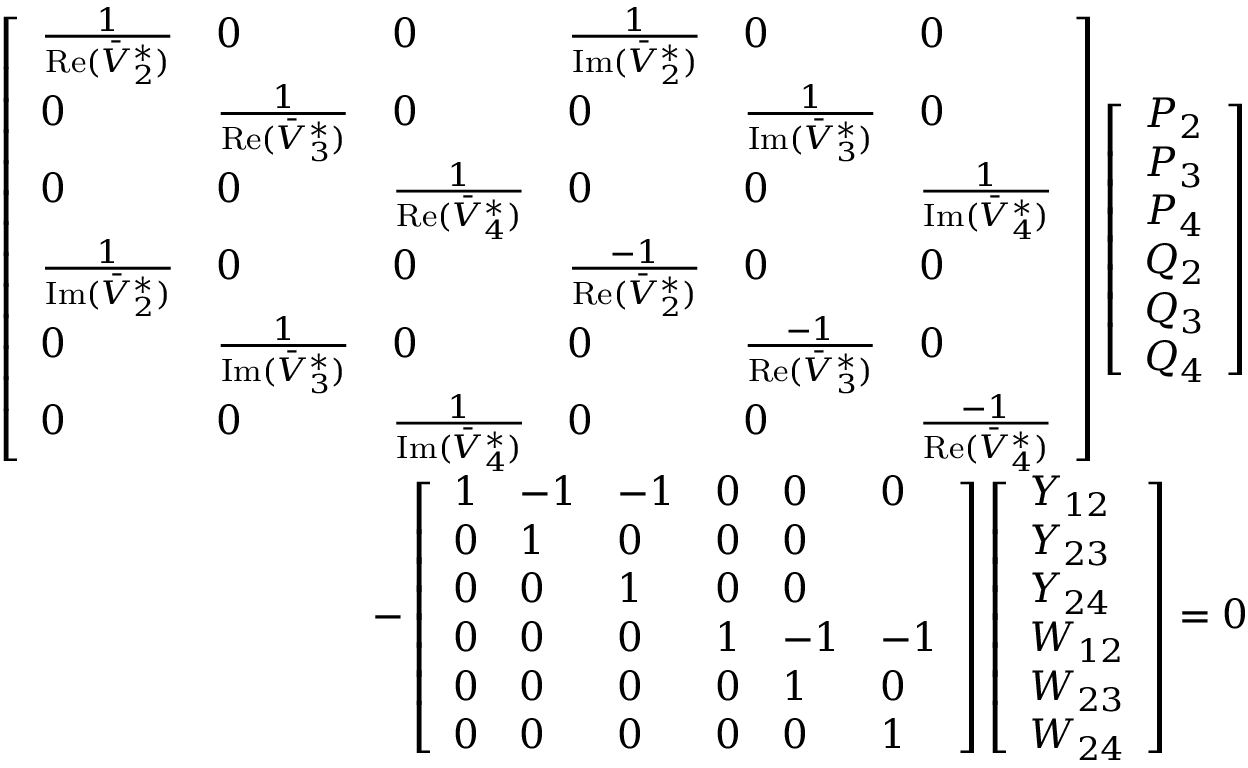Convert formula to latex. <formula><loc_0><loc_0><loc_500><loc_500>\begin{array} { r } { \left [ \begin{array} { l l l l l l } { \frac { 1 } { R e ( \bar { V } _ { 2 } ^ { * } ) } } & { 0 } & { 0 } & { \frac { 1 } { I m ( \bar { V } _ { 2 } ^ { * } ) } } & { 0 } & { 0 } \\ { 0 } & { \frac { 1 } { R e ( \bar { V } _ { 3 } ^ { * } ) } } & { 0 } & { 0 } & { \frac { 1 } { I m ( \bar { V } _ { 3 } ^ { * } ) } } & { 0 } \\ { 0 } & { 0 } & { \frac { 1 } { R e ( \bar { V } _ { 4 } ^ { * } ) } } & { 0 } & { 0 } & { \frac { 1 } { I m ( \bar { V } _ { 4 } ^ { * } ) } } \\ { \frac { 1 } { I m ( \bar { V } _ { 2 } ^ { * } ) } } & { 0 } & { 0 } & { \frac { - 1 } { R e ( \bar { V } _ { 2 } ^ { * } ) } } & { 0 } & { 0 } \\ { 0 } & { \frac { 1 } { I m ( \bar { V } _ { 3 } ^ { * } ) } } & { 0 } & { 0 } & { \frac { - 1 } { R e ( \bar { V } _ { 3 } ^ { * } ) } } & { 0 } \\ { 0 } & { 0 } & { \frac { 1 } { I m ( \bar { V } _ { 4 } ^ { * } ) } } & { 0 } & { 0 } & { \frac { - 1 } { R e ( \bar { V } _ { 4 } ^ { * } ) } } \end{array} \right ] \left [ \begin{array} { l } { P _ { 2 } } \\ { P _ { 3 } } \\ { P _ { 4 } } \\ { Q _ { 2 } } \\ { Q _ { 3 } } \\ { Q _ { 4 } } \end{array} \right ] } \\ { - \left [ \begin{array} { l l l l l l } { 1 } & { - 1 } & { - 1 } & { 0 } & { 0 } & { 0 } \\ { 0 } & { 1 } & { 0 } & { 0 } & { 0 } \\ { 0 } & { 0 } & { 1 } & { 0 } & { 0 } \\ { 0 } & { 0 } & { 0 } & { 1 } & { - 1 } & { - 1 } \\ { 0 } & { 0 } & { 0 } & { 0 } & { 1 } & { 0 } \\ { 0 } & { 0 } & { 0 } & { 0 } & { 0 } & { 1 } \end{array} \right ] \left [ \begin{array} { l } { Y _ { 1 2 } } \\ { Y _ { 2 3 } } \\ { Y _ { 2 4 } } \\ { W _ { 1 2 } } \\ { W _ { 2 3 } } \\ { W _ { 2 4 } } \end{array} \right ] = 0 } \end{array}</formula> 